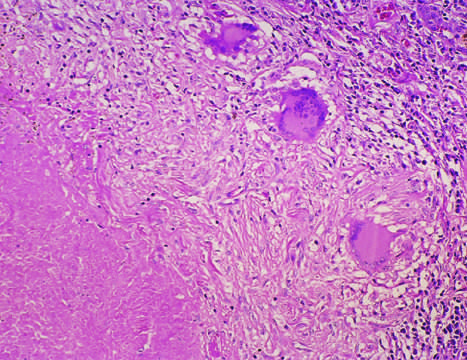does a characteristic tubercle at low magnification show central granular caseation surrounded by epithelioid and multinucleate giant cells?
Answer the question using a single word or phrase. Yes 